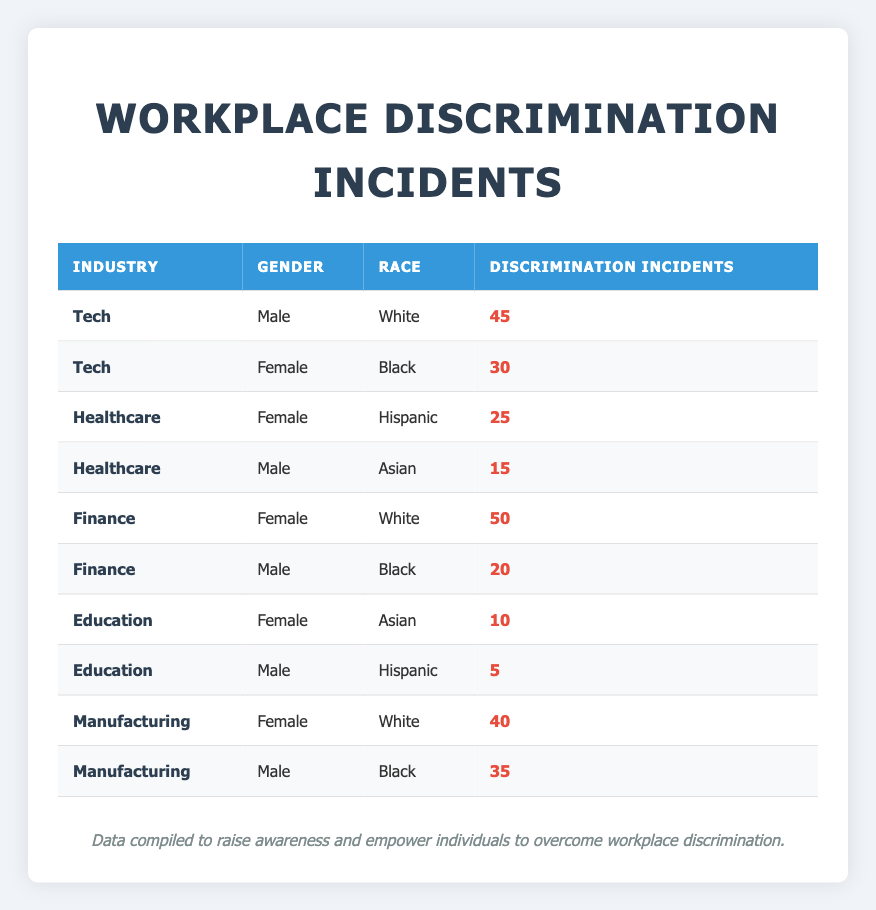What industry has the highest number of discrimination incidents for females? In the table, the Finance industry has two data points for females: 50 incidents for White females and 0 incidents for Black females. The highest value is 50.
Answer: Finance What is the total number of discrimination incidents in the Tech industry? The Tech industry has two incidents recorded: 45 for White males and 30 for Black females. Adding these two values gives us 45 + 30 = 75.
Answer: 75 Is there any recorded discrimination incident for Hispanic females in Education? There is no record of discrimination incidents for Hispanic females in the Education sector, as the female incidents listed are for Asian females only with 10 incidents.
Answer: No What is the difference in discrimination incidents between female and male workers in the Finance industry? In the Finance industry, there are 50 incidents for females and 20 for males. Calculating the difference, 50 - 20 = 30.
Answer: 30 Which demographic has the lowest number of discrimination incidents in the Education industry? In the Education sector, the male Hispanic group has 5 incidents, which is lower than the female Asian group with 10 incidents. Therefore, the lowest number is for male Hispanics.
Answer: Male Hispanic What is the total number of discrimination incidents for White workers across all industries? Adding the incidents for White workers from different industries: 45 (Tech, Male) + 50 (Finance, Female) + 40 (Manufacturing, Female) = 135.
Answer: 135 Are there more discrimination incidents for women in the Manufacturing industry compared to the Healthcare industry? In the Manufacturing industry, females have 40 incidents, while in the Healthcare industry, females have 25 incidents. Since 40 (Manufacturing) is greater than 25 (Healthcare), the answer is yes.
Answer: Yes What is the average number of discrimination incidents for male workers in the Tech and Finance industries? For male workers in Tech, there are 45 incidents, and in Finance, there are 20 incidents. To find the average, we sum these numbers: 45 + 20 = 65, and divide by the number of groups, which is 2. So, 65/2 = 32.5.
Answer: 32.5 Which industry has the highest overall number of discrimination incidents across all demographics? Calculating the total for each industry: Tech has 75, Healthcare has 40, Finance has 70, Education has 15, and Manufacturing has 75. The highest total is 75, which is shared by Tech and Manufacturing.
Answer: Tech and Manufacturing 